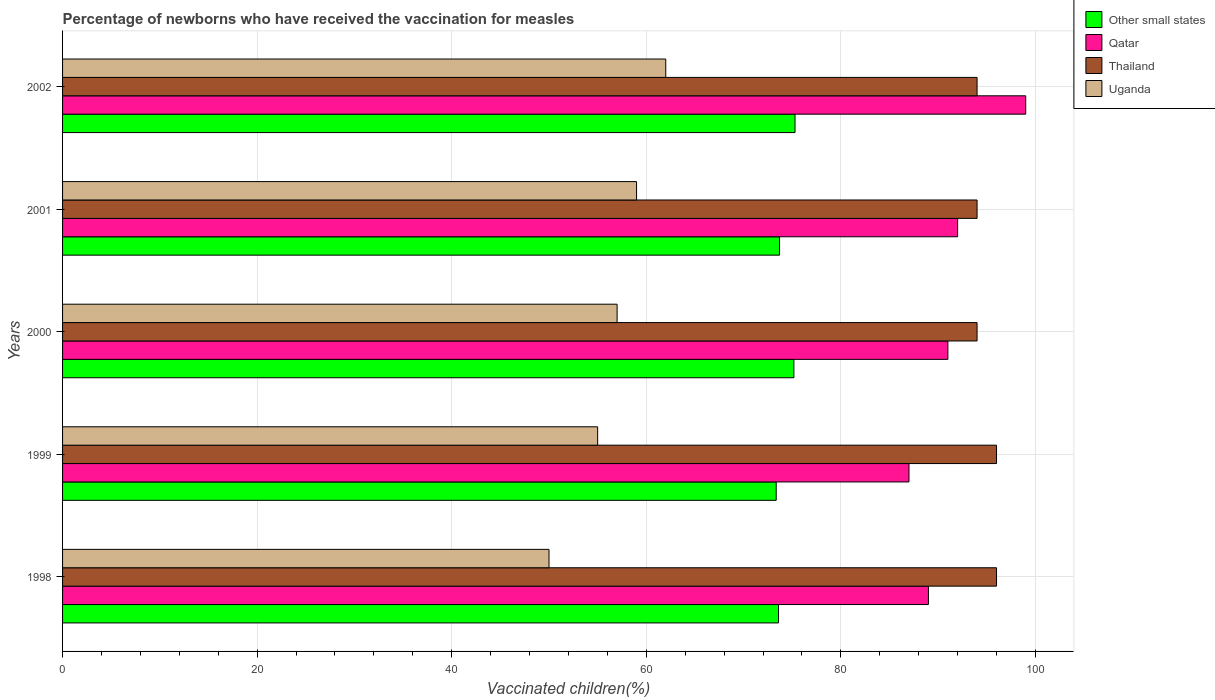How many different coloured bars are there?
Provide a succinct answer. 4. Are the number of bars per tick equal to the number of legend labels?
Make the answer very short. Yes. How many bars are there on the 5th tick from the top?
Keep it short and to the point. 4. What is the label of the 5th group of bars from the top?
Give a very brief answer. 1998. In how many cases, is the number of bars for a given year not equal to the number of legend labels?
Provide a short and direct response. 0. What is the percentage of vaccinated children in Other small states in 2002?
Your answer should be very brief. 75.29. Across all years, what is the maximum percentage of vaccinated children in Thailand?
Your answer should be compact. 96. Across all years, what is the minimum percentage of vaccinated children in Qatar?
Your answer should be very brief. 87. In which year was the percentage of vaccinated children in Uganda maximum?
Ensure brevity in your answer.  2002. What is the total percentage of vaccinated children in Thailand in the graph?
Keep it short and to the point. 474. What is the difference between the percentage of vaccinated children in Thailand in 2000 and that in 2002?
Give a very brief answer. 0. What is the difference between the percentage of vaccinated children in Qatar in 1998 and the percentage of vaccinated children in Thailand in 2002?
Give a very brief answer. -5. What is the average percentage of vaccinated children in Other small states per year?
Provide a short and direct response. 74.22. In the year 2000, what is the difference between the percentage of vaccinated children in Other small states and percentage of vaccinated children in Qatar?
Your answer should be very brief. -15.83. In how many years, is the percentage of vaccinated children in Qatar greater than 28 %?
Keep it short and to the point. 5. What is the ratio of the percentage of vaccinated children in Qatar in 1999 to that in 2000?
Your answer should be compact. 0.96. Is the percentage of vaccinated children in Thailand in 1998 less than that in 1999?
Provide a succinct answer. No. What is the difference between the highest and the second highest percentage of vaccinated children in Thailand?
Offer a very short reply. 0. What does the 1st bar from the top in 1998 represents?
Offer a terse response. Uganda. What does the 3rd bar from the bottom in 2001 represents?
Offer a terse response. Thailand. Is it the case that in every year, the sum of the percentage of vaccinated children in Thailand and percentage of vaccinated children in Qatar is greater than the percentage of vaccinated children in Other small states?
Ensure brevity in your answer.  Yes. How many bars are there?
Your answer should be compact. 20. Are all the bars in the graph horizontal?
Give a very brief answer. Yes. What is the difference between two consecutive major ticks on the X-axis?
Provide a succinct answer. 20. Are the values on the major ticks of X-axis written in scientific E-notation?
Make the answer very short. No. Does the graph contain any zero values?
Offer a very short reply. No. Where does the legend appear in the graph?
Give a very brief answer. Top right. How are the legend labels stacked?
Your response must be concise. Vertical. What is the title of the graph?
Your answer should be very brief. Percentage of newborns who have received the vaccination for measles. Does "Tuvalu" appear as one of the legend labels in the graph?
Keep it short and to the point. No. What is the label or title of the X-axis?
Your answer should be compact. Vaccinated children(%). What is the Vaccinated children(%) of Other small states in 1998?
Keep it short and to the point. 73.59. What is the Vaccinated children(%) in Qatar in 1998?
Provide a succinct answer. 89. What is the Vaccinated children(%) of Thailand in 1998?
Make the answer very short. 96. What is the Vaccinated children(%) in Uganda in 1998?
Keep it short and to the point. 50. What is the Vaccinated children(%) in Other small states in 1999?
Your response must be concise. 73.35. What is the Vaccinated children(%) of Qatar in 1999?
Ensure brevity in your answer.  87. What is the Vaccinated children(%) in Thailand in 1999?
Make the answer very short. 96. What is the Vaccinated children(%) in Uganda in 1999?
Your answer should be very brief. 55. What is the Vaccinated children(%) of Other small states in 2000?
Give a very brief answer. 75.17. What is the Vaccinated children(%) in Qatar in 2000?
Provide a succinct answer. 91. What is the Vaccinated children(%) in Thailand in 2000?
Your response must be concise. 94. What is the Vaccinated children(%) of Other small states in 2001?
Make the answer very short. 73.7. What is the Vaccinated children(%) of Qatar in 2001?
Make the answer very short. 92. What is the Vaccinated children(%) of Thailand in 2001?
Make the answer very short. 94. What is the Vaccinated children(%) of Uganda in 2001?
Offer a terse response. 59. What is the Vaccinated children(%) of Other small states in 2002?
Ensure brevity in your answer.  75.29. What is the Vaccinated children(%) in Thailand in 2002?
Provide a succinct answer. 94. What is the Vaccinated children(%) in Uganda in 2002?
Make the answer very short. 62. Across all years, what is the maximum Vaccinated children(%) of Other small states?
Give a very brief answer. 75.29. Across all years, what is the maximum Vaccinated children(%) of Thailand?
Offer a terse response. 96. Across all years, what is the minimum Vaccinated children(%) in Other small states?
Offer a terse response. 73.35. Across all years, what is the minimum Vaccinated children(%) of Qatar?
Make the answer very short. 87. Across all years, what is the minimum Vaccinated children(%) in Thailand?
Make the answer very short. 94. What is the total Vaccinated children(%) in Other small states in the graph?
Your answer should be compact. 371.09. What is the total Vaccinated children(%) in Qatar in the graph?
Offer a very short reply. 458. What is the total Vaccinated children(%) in Thailand in the graph?
Your answer should be compact. 474. What is the total Vaccinated children(%) of Uganda in the graph?
Make the answer very short. 283. What is the difference between the Vaccinated children(%) of Other small states in 1998 and that in 1999?
Your response must be concise. 0.24. What is the difference between the Vaccinated children(%) of Qatar in 1998 and that in 1999?
Offer a terse response. 2. What is the difference between the Vaccinated children(%) in Other small states in 1998 and that in 2000?
Offer a terse response. -1.58. What is the difference between the Vaccinated children(%) in Qatar in 1998 and that in 2000?
Offer a terse response. -2. What is the difference between the Vaccinated children(%) of Uganda in 1998 and that in 2000?
Provide a succinct answer. -7. What is the difference between the Vaccinated children(%) of Other small states in 1998 and that in 2001?
Your answer should be very brief. -0.1. What is the difference between the Vaccinated children(%) of Qatar in 1998 and that in 2001?
Ensure brevity in your answer.  -3. What is the difference between the Vaccinated children(%) of Thailand in 1998 and that in 2001?
Make the answer very short. 2. What is the difference between the Vaccinated children(%) in Uganda in 1998 and that in 2001?
Your response must be concise. -9. What is the difference between the Vaccinated children(%) in Other small states in 1998 and that in 2002?
Your answer should be very brief. -1.7. What is the difference between the Vaccinated children(%) of Qatar in 1998 and that in 2002?
Make the answer very short. -10. What is the difference between the Vaccinated children(%) in Uganda in 1998 and that in 2002?
Provide a succinct answer. -12. What is the difference between the Vaccinated children(%) in Other small states in 1999 and that in 2000?
Your response must be concise. -1.82. What is the difference between the Vaccinated children(%) in Other small states in 1999 and that in 2001?
Your answer should be compact. -0.34. What is the difference between the Vaccinated children(%) of Qatar in 1999 and that in 2001?
Provide a succinct answer. -5. What is the difference between the Vaccinated children(%) in Thailand in 1999 and that in 2001?
Keep it short and to the point. 2. What is the difference between the Vaccinated children(%) of Uganda in 1999 and that in 2001?
Your response must be concise. -4. What is the difference between the Vaccinated children(%) of Other small states in 1999 and that in 2002?
Ensure brevity in your answer.  -1.93. What is the difference between the Vaccinated children(%) of Qatar in 1999 and that in 2002?
Give a very brief answer. -12. What is the difference between the Vaccinated children(%) of Uganda in 1999 and that in 2002?
Give a very brief answer. -7. What is the difference between the Vaccinated children(%) in Other small states in 2000 and that in 2001?
Provide a succinct answer. 1.47. What is the difference between the Vaccinated children(%) of Qatar in 2000 and that in 2001?
Your response must be concise. -1. What is the difference between the Vaccinated children(%) of Other small states in 2000 and that in 2002?
Provide a succinct answer. -0.12. What is the difference between the Vaccinated children(%) of Thailand in 2000 and that in 2002?
Offer a terse response. 0. What is the difference between the Vaccinated children(%) in Uganda in 2000 and that in 2002?
Offer a very short reply. -5. What is the difference between the Vaccinated children(%) of Other small states in 2001 and that in 2002?
Keep it short and to the point. -1.59. What is the difference between the Vaccinated children(%) in Qatar in 2001 and that in 2002?
Provide a short and direct response. -7. What is the difference between the Vaccinated children(%) of Uganda in 2001 and that in 2002?
Provide a succinct answer. -3. What is the difference between the Vaccinated children(%) of Other small states in 1998 and the Vaccinated children(%) of Qatar in 1999?
Provide a short and direct response. -13.41. What is the difference between the Vaccinated children(%) in Other small states in 1998 and the Vaccinated children(%) in Thailand in 1999?
Give a very brief answer. -22.41. What is the difference between the Vaccinated children(%) in Other small states in 1998 and the Vaccinated children(%) in Uganda in 1999?
Give a very brief answer. 18.59. What is the difference between the Vaccinated children(%) of Thailand in 1998 and the Vaccinated children(%) of Uganda in 1999?
Make the answer very short. 41. What is the difference between the Vaccinated children(%) in Other small states in 1998 and the Vaccinated children(%) in Qatar in 2000?
Your answer should be compact. -17.41. What is the difference between the Vaccinated children(%) of Other small states in 1998 and the Vaccinated children(%) of Thailand in 2000?
Make the answer very short. -20.41. What is the difference between the Vaccinated children(%) of Other small states in 1998 and the Vaccinated children(%) of Uganda in 2000?
Offer a very short reply. 16.59. What is the difference between the Vaccinated children(%) of Qatar in 1998 and the Vaccinated children(%) of Thailand in 2000?
Your answer should be compact. -5. What is the difference between the Vaccinated children(%) of Thailand in 1998 and the Vaccinated children(%) of Uganda in 2000?
Offer a terse response. 39. What is the difference between the Vaccinated children(%) of Other small states in 1998 and the Vaccinated children(%) of Qatar in 2001?
Ensure brevity in your answer.  -18.41. What is the difference between the Vaccinated children(%) in Other small states in 1998 and the Vaccinated children(%) in Thailand in 2001?
Provide a succinct answer. -20.41. What is the difference between the Vaccinated children(%) of Other small states in 1998 and the Vaccinated children(%) of Uganda in 2001?
Ensure brevity in your answer.  14.59. What is the difference between the Vaccinated children(%) in Qatar in 1998 and the Vaccinated children(%) in Thailand in 2001?
Make the answer very short. -5. What is the difference between the Vaccinated children(%) in Thailand in 1998 and the Vaccinated children(%) in Uganda in 2001?
Make the answer very short. 37. What is the difference between the Vaccinated children(%) in Other small states in 1998 and the Vaccinated children(%) in Qatar in 2002?
Provide a succinct answer. -25.41. What is the difference between the Vaccinated children(%) of Other small states in 1998 and the Vaccinated children(%) of Thailand in 2002?
Make the answer very short. -20.41. What is the difference between the Vaccinated children(%) of Other small states in 1998 and the Vaccinated children(%) of Uganda in 2002?
Offer a very short reply. 11.59. What is the difference between the Vaccinated children(%) of Qatar in 1998 and the Vaccinated children(%) of Thailand in 2002?
Offer a terse response. -5. What is the difference between the Vaccinated children(%) in Qatar in 1998 and the Vaccinated children(%) in Uganda in 2002?
Offer a terse response. 27. What is the difference between the Vaccinated children(%) of Other small states in 1999 and the Vaccinated children(%) of Qatar in 2000?
Provide a succinct answer. -17.65. What is the difference between the Vaccinated children(%) of Other small states in 1999 and the Vaccinated children(%) of Thailand in 2000?
Offer a very short reply. -20.65. What is the difference between the Vaccinated children(%) in Other small states in 1999 and the Vaccinated children(%) in Uganda in 2000?
Keep it short and to the point. 16.35. What is the difference between the Vaccinated children(%) of Qatar in 1999 and the Vaccinated children(%) of Thailand in 2000?
Keep it short and to the point. -7. What is the difference between the Vaccinated children(%) in Qatar in 1999 and the Vaccinated children(%) in Uganda in 2000?
Keep it short and to the point. 30. What is the difference between the Vaccinated children(%) in Thailand in 1999 and the Vaccinated children(%) in Uganda in 2000?
Your answer should be very brief. 39. What is the difference between the Vaccinated children(%) in Other small states in 1999 and the Vaccinated children(%) in Qatar in 2001?
Your response must be concise. -18.65. What is the difference between the Vaccinated children(%) of Other small states in 1999 and the Vaccinated children(%) of Thailand in 2001?
Your response must be concise. -20.65. What is the difference between the Vaccinated children(%) in Other small states in 1999 and the Vaccinated children(%) in Uganda in 2001?
Give a very brief answer. 14.35. What is the difference between the Vaccinated children(%) of Qatar in 1999 and the Vaccinated children(%) of Uganda in 2001?
Offer a terse response. 28. What is the difference between the Vaccinated children(%) of Thailand in 1999 and the Vaccinated children(%) of Uganda in 2001?
Give a very brief answer. 37. What is the difference between the Vaccinated children(%) of Other small states in 1999 and the Vaccinated children(%) of Qatar in 2002?
Make the answer very short. -25.65. What is the difference between the Vaccinated children(%) of Other small states in 1999 and the Vaccinated children(%) of Thailand in 2002?
Your answer should be compact. -20.65. What is the difference between the Vaccinated children(%) in Other small states in 1999 and the Vaccinated children(%) in Uganda in 2002?
Make the answer very short. 11.35. What is the difference between the Vaccinated children(%) in Qatar in 1999 and the Vaccinated children(%) in Thailand in 2002?
Keep it short and to the point. -7. What is the difference between the Vaccinated children(%) in Thailand in 1999 and the Vaccinated children(%) in Uganda in 2002?
Your answer should be very brief. 34. What is the difference between the Vaccinated children(%) of Other small states in 2000 and the Vaccinated children(%) of Qatar in 2001?
Provide a short and direct response. -16.83. What is the difference between the Vaccinated children(%) in Other small states in 2000 and the Vaccinated children(%) in Thailand in 2001?
Make the answer very short. -18.83. What is the difference between the Vaccinated children(%) in Other small states in 2000 and the Vaccinated children(%) in Uganda in 2001?
Ensure brevity in your answer.  16.17. What is the difference between the Vaccinated children(%) in Qatar in 2000 and the Vaccinated children(%) in Thailand in 2001?
Ensure brevity in your answer.  -3. What is the difference between the Vaccinated children(%) in Qatar in 2000 and the Vaccinated children(%) in Uganda in 2001?
Provide a short and direct response. 32. What is the difference between the Vaccinated children(%) in Thailand in 2000 and the Vaccinated children(%) in Uganda in 2001?
Your answer should be very brief. 35. What is the difference between the Vaccinated children(%) in Other small states in 2000 and the Vaccinated children(%) in Qatar in 2002?
Your answer should be very brief. -23.83. What is the difference between the Vaccinated children(%) in Other small states in 2000 and the Vaccinated children(%) in Thailand in 2002?
Offer a very short reply. -18.83. What is the difference between the Vaccinated children(%) of Other small states in 2000 and the Vaccinated children(%) of Uganda in 2002?
Your answer should be compact. 13.17. What is the difference between the Vaccinated children(%) in Qatar in 2000 and the Vaccinated children(%) in Thailand in 2002?
Your response must be concise. -3. What is the difference between the Vaccinated children(%) in Thailand in 2000 and the Vaccinated children(%) in Uganda in 2002?
Offer a terse response. 32. What is the difference between the Vaccinated children(%) of Other small states in 2001 and the Vaccinated children(%) of Qatar in 2002?
Ensure brevity in your answer.  -25.3. What is the difference between the Vaccinated children(%) in Other small states in 2001 and the Vaccinated children(%) in Thailand in 2002?
Give a very brief answer. -20.3. What is the difference between the Vaccinated children(%) in Other small states in 2001 and the Vaccinated children(%) in Uganda in 2002?
Offer a terse response. 11.7. What is the difference between the Vaccinated children(%) in Qatar in 2001 and the Vaccinated children(%) in Thailand in 2002?
Give a very brief answer. -2. What is the average Vaccinated children(%) in Other small states per year?
Your answer should be compact. 74.22. What is the average Vaccinated children(%) in Qatar per year?
Your answer should be very brief. 91.6. What is the average Vaccinated children(%) in Thailand per year?
Your answer should be compact. 94.8. What is the average Vaccinated children(%) in Uganda per year?
Your response must be concise. 56.6. In the year 1998, what is the difference between the Vaccinated children(%) in Other small states and Vaccinated children(%) in Qatar?
Provide a succinct answer. -15.41. In the year 1998, what is the difference between the Vaccinated children(%) of Other small states and Vaccinated children(%) of Thailand?
Give a very brief answer. -22.41. In the year 1998, what is the difference between the Vaccinated children(%) of Other small states and Vaccinated children(%) of Uganda?
Your response must be concise. 23.59. In the year 1998, what is the difference between the Vaccinated children(%) in Qatar and Vaccinated children(%) in Thailand?
Give a very brief answer. -7. In the year 1998, what is the difference between the Vaccinated children(%) in Qatar and Vaccinated children(%) in Uganda?
Ensure brevity in your answer.  39. In the year 1998, what is the difference between the Vaccinated children(%) in Thailand and Vaccinated children(%) in Uganda?
Make the answer very short. 46. In the year 1999, what is the difference between the Vaccinated children(%) of Other small states and Vaccinated children(%) of Qatar?
Offer a terse response. -13.65. In the year 1999, what is the difference between the Vaccinated children(%) of Other small states and Vaccinated children(%) of Thailand?
Offer a very short reply. -22.65. In the year 1999, what is the difference between the Vaccinated children(%) of Other small states and Vaccinated children(%) of Uganda?
Offer a very short reply. 18.35. In the year 2000, what is the difference between the Vaccinated children(%) of Other small states and Vaccinated children(%) of Qatar?
Provide a succinct answer. -15.83. In the year 2000, what is the difference between the Vaccinated children(%) in Other small states and Vaccinated children(%) in Thailand?
Make the answer very short. -18.83. In the year 2000, what is the difference between the Vaccinated children(%) in Other small states and Vaccinated children(%) in Uganda?
Ensure brevity in your answer.  18.17. In the year 2000, what is the difference between the Vaccinated children(%) in Qatar and Vaccinated children(%) in Thailand?
Keep it short and to the point. -3. In the year 2001, what is the difference between the Vaccinated children(%) of Other small states and Vaccinated children(%) of Qatar?
Make the answer very short. -18.3. In the year 2001, what is the difference between the Vaccinated children(%) in Other small states and Vaccinated children(%) in Thailand?
Keep it short and to the point. -20.3. In the year 2001, what is the difference between the Vaccinated children(%) in Other small states and Vaccinated children(%) in Uganda?
Your response must be concise. 14.7. In the year 2001, what is the difference between the Vaccinated children(%) of Qatar and Vaccinated children(%) of Thailand?
Offer a very short reply. -2. In the year 2002, what is the difference between the Vaccinated children(%) of Other small states and Vaccinated children(%) of Qatar?
Provide a short and direct response. -23.71. In the year 2002, what is the difference between the Vaccinated children(%) of Other small states and Vaccinated children(%) of Thailand?
Provide a short and direct response. -18.71. In the year 2002, what is the difference between the Vaccinated children(%) in Other small states and Vaccinated children(%) in Uganda?
Offer a terse response. 13.29. In the year 2002, what is the difference between the Vaccinated children(%) in Qatar and Vaccinated children(%) in Uganda?
Your answer should be compact. 37. In the year 2002, what is the difference between the Vaccinated children(%) of Thailand and Vaccinated children(%) of Uganda?
Offer a terse response. 32. What is the ratio of the Vaccinated children(%) of Qatar in 1998 to that in 1999?
Make the answer very short. 1.02. What is the ratio of the Vaccinated children(%) in Thailand in 1998 to that in 1999?
Give a very brief answer. 1. What is the ratio of the Vaccinated children(%) of Uganda in 1998 to that in 1999?
Provide a short and direct response. 0.91. What is the ratio of the Vaccinated children(%) of Thailand in 1998 to that in 2000?
Your answer should be compact. 1.02. What is the ratio of the Vaccinated children(%) in Uganda in 1998 to that in 2000?
Give a very brief answer. 0.88. What is the ratio of the Vaccinated children(%) of Other small states in 1998 to that in 2001?
Your response must be concise. 1. What is the ratio of the Vaccinated children(%) in Qatar in 1998 to that in 2001?
Provide a succinct answer. 0.97. What is the ratio of the Vaccinated children(%) in Thailand in 1998 to that in 2001?
Ensure brevity in your answer.  1.02. What is the ratio of the Vaccinated children(%) in Uganda in 1998 to that in 2001?
Provide a succinct answer. 0.85. What is the ratio of the Vaccinated children(%) in Other small states in 1998 to that in 2002?
Make the answer very short. 0.98. What is the ratio of the Vaccinated children(%) of Qatar in 1998 to that in 2002?
Offer a very short reply. 0.9. What is the ratio of the Vaccinated children(%) of Thailand in 1998 to that in 2002?
Provide a succinct answer. 1.02. What is the ratio of the Vaccinated children(%) in Uganda in 1998 to that in 2002?
Provide a short and direct response. 0.81. What is the ratio of the Vaccinated children(%) in Other small states in 1999 to that in 2000?
Offer a very short reply. 0.98. What is the ratio of the Vaccinated children(%) in Qatar in 1999 to that in 2000?
Offer a very short reply. 0.96. What is the ratio of the Vaccinated children(%) of Thailand in 1999 to that in 2000?
Your answer should be compact. 1.02. What is the ratio of the Vaccinated children(%) in Uganda in 1999 to that in 2000?
Make the answer very short. 0.96. What is the ratio of the Vaccinated children(%) in Qatar in 1999 to that in 2001?
Ensure brevity in your answer.  0.95. What is the ratio of the Vaccinated children(%) of Thailand in 1999 to that in 2001?
Ensure brevity in your answer.  1.02. What is the ratio of the Vaccinated children(%) in Uganda in 1999 to that in 2001?
Offer a terse response. 0.93. What is the ratio of the Vaccinated children(%) of Other small states in 1999 to that in 2002?
Give a very brief answer. 0.97. What is the ratio of the Vaccinated children(%) in Qatar in 1999 to that in 2002?
Offer a terse response. 0.88. What is the ratio of the Vaccinated children(%) in Thailand in 1999 to that in 2002?
Provide a succinct answer. 1.02. What is the ratio of the Vaccinated children(%) of Uganda in 1999 to that in 2002?
Ensure brevity in your answer.  0.89. What is the ratio of the Vaccinated children(%) in Other small states in 2000 to that in 2001?
Ensure brevity in your answer.  1.02. What is the ratio of the Vaccinated children(%) in Qatar in 2000 to that in 2001?
Provide a succinct answer. 0.99. What is the ratio of the Vaccinated children(%) in Uganda in 2000 to that in 2001?
Ensure brevity in your answer.  0.97. What is the ratio of the Vaccinated children(%) of Qatar in 2000 to that in 2002?
Your answer should be compact. 0.92. What is the ratio of the Vaccinated children(%) in Thailand in 2000 to that in 2002?
Keep it short and to the point. 1. What is the ratio of the Vaccinated children(%) in Uganda in 2000 to that in 2002?
Your answer should be compact. 0.92. What is the ratio of the Vaccinated children(%) of Other small states in 2001 to that in 2002?
Provide a succinct answer. 0.98. What is the ratio of the Vaccinated children(%) in Qatar in 2001 to that in 2002?
Provide a short and direct response. 0.93. What is the ratio of the Vaccinated children(%) in Uganda in 2001 to that in 2002?
Your answer should be very brief. 0.95. What is the difference between the highest and the second highest Vaccinated children(%) in Other small states?
Make the answer very short. 0.12. What is the difference between the highest and the second highest Vaccinated children(%) of Qatar?
Offer a terse response. 7. What is the difference between the highest and the second highest Vaccinated children(%) in Thailand?
Your answer should be compact. 0. What is the difference between the highest and the second highest Vaccinated children(%) in Uganda?
Your answer should be very brief. 3. What is the difference between the highest and the lowest Vaccinated children(%) in Other small states?
Your answer should be very brief. 1.93. What is the difference between the highest and the lowest Vaccinated children(%) in Uganda?
Provide a short and direct response. 12. 